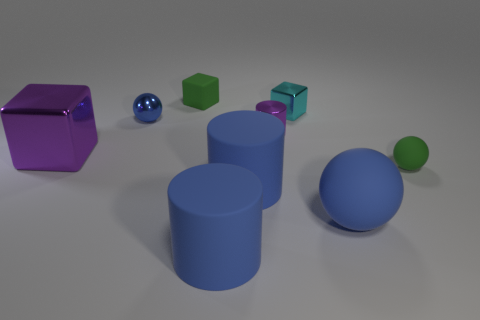Can you tell me how many objects in the image have a cylindrical shape? Yes, there are two objects in the image with a cylindrical shape. These are the two upright blue cylinders, which might represent pillars or stand-ins for industrial components in a simplistic model. 